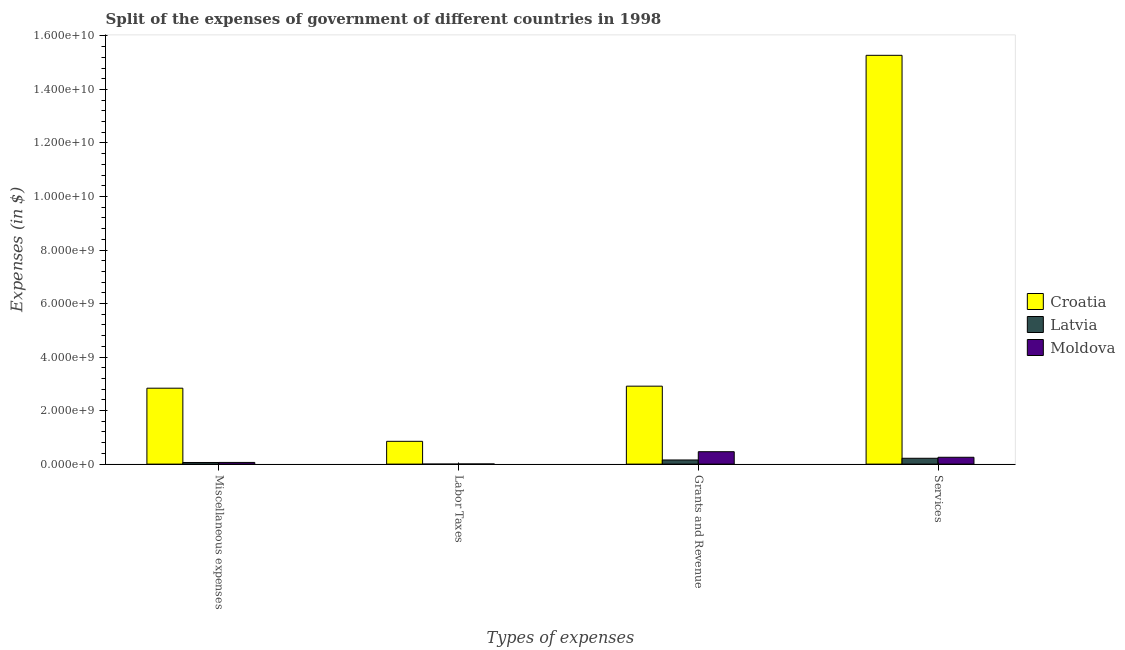Are the number of bars on each tick of the X-axis equal?
Ensure brevity in your answer.  Yes. How many bars are there on the 2nd tick from the left?
Offer a very short reply. 3. What is the label of the 4th group of bars from the left?
Keep it short and to the point. Services. What is the amount spent on labor taxes in Latvia?
Provide a succinct answer. 1.10e+05. Across all countries, what is the maximum amount spent on miscellaneous expenses?
Ensure brevity in your answer.  2.84e+09. Across all countries, what is the minimum amount spent on labor taxes?
Your answer should be very brief. 1.10e+05. In which country was the amount spent on miscellaneous expenses maximum?
Give a very brief answer. Croatia. In which country was the amount spent on labor taxes minimum?
Keep it short and to the point. Latvia. What is the total amount spent on grants and revenue in the graph?
Provide a short and direct response. 3.53e+09. What is the difference between the amount spent on labor taxes in Croatia and that in Moldova?
Provide a short and direct response. 8.46e+08. What is the difference between the amount spent on services in Latvia and the amount spent on labor taxes in Croatia?
Give a very brief answer. -6.33e+08. What is the average amount spent on grants and revenue per country?
Make the answer very short. 1.18e+09. What is the difference between the amount spent on miscellaneous expenses and amount spent on services in Croatia?
Offer a terse response. -1.24e+1. In how many countries, is the amount spent on grants and revenue greater than 400000000 $?
Give a very brief answer. 2. What is the ratio of the amount spent on miscellaneous expenses in Latvia to that in Croatia?
Your answer should be very brief. 0.02. Is the difference between the amount spent on labor taxes in Moldova and Latvia greater than the difference between the amount spent on miscellaneous expenses in Moldova and Latvia?
Your answer should be compact. Yes. What is the difference between the highest and the second highest amount spent on services?
Give a very brief answer. 1.50e+1. What is the difference between the highest and the lowest amount spent on services?
Offer a very short reply. 1.51e+1. Is it the case that in every country, the sum of the amount spent on miscellaneous expenses and amount spent on services is greater than the sum of amount spent on labor taxes and amount spent on grants and revenue?
Offer a very short reply. Yes. What does the 1st bar from the left in Labor Taxes represents?
Provide a succinct answer. Croatia. What does the 1st bar from the right in Miscellaneous expenses represents?
Your answer should be compact. Moldova. Is it the case that in every country, the sum of the amount spent on miscellaneous expenses and amount spent on labor taxes is greater than the amount spent on grants and revenue?
Provide a succinct answer. No. Are all the bars in the graph horizontal?
Give a very brief answer. No. How many countries are there in the graph?
Your answer should be compact. 3. How many legend labels are there?
Your response must be concise. 3. What is the title of the graph?
Make the answer very short. Split of the expenses of government of different countries in 1998. Does "Norway" appear as one of the legend labels in the graph?
Your answer should be compact. No. What is the label or title of the X-axis?
Keep it short and to the point. Types of expenses. What is the label or title of the Y-axis?
Provide a succinct answer. Expenses (in $). What is the Expenses (in $) of Croatia in Miscellaneous expenses?
Provide a short and direct response. 2.84e+09. What is the Expenses (in $) of Latvia in Miscellaneous expenses?
Ensure brevity in your answer.  6.06e+07. What is the Expenses (in $) in Moldova in Miscellaneous expenses?
Offer a very short reply. 6.28e+07. What is the Expenses (in $) in Croatia in Labor Taxes?
Give a very brief answer. 8.52e+08. What is the Expenses (in $) in Latvia in Labor Taxes?
Your response must be concise. 1.10e+05. What is the Expenses (in $) of Moldova in Labor Taxes?
Provide a short and direct response. 5.40e+06. What is the Expenses (in $) in Croatia in Grants and Revenue?
Provide a succinct answer. 2.91e+09. What is the Expenses (in $) in Latvia in Grants and Revenue?
Provide a succinct answer. 1.55e+08. What is the Expenses (in $) in Moldova in Grants and Revenue?
Provide a short and direct response. 4.64e+08. What is the Expenses (in $) of Croatia in Services?
Your answer should be very brief. 1.53e+1. What is the Expenses (in $) of Latvia in Services?
Provide a succinct answer. 2.18e+08. What is the Expenses (in $) in Moldova in Services?
Offer a terse response. 2.55e+08. Across all Types of expenses, what is the maximum Expenses (in $) in Croatia?
Your answer should be compact. 1.53e+1. Across all Types of expenses, what is the maximum Expenses (in $) in Latvia?
Your response must be concise. 2.18e+08. Across all Types of expenses, what is the maximum Expenses (in $) in Moldova?
Make the answer very short. 4.64e+08. Across all Types of expenses, what is the minimum Expenses (in $) of Croatia?
Give a very brief answer. 8.52e+08. Across all Types of expenses, what is the minimum Expenses (in $) in Moldova?
Provide a succinct answer. 5.40e+06. What is the total Expenses (in $) of Croatia in the graph?
Your answer should be very brief. 2.19e+1. What is the total Expenses (in $) in Latvia in the graph?
Provide a succinct answer. 4.34e+08. What is the total Expenses (in $) in Moldova in the graph?
Your answer should be compact. 7.87e+08. What is the difference between the Expenses (in $) in Croatia in Miscellaneous expenses and that in Labor Taxes?
Give a very brief answer. 1.98e+09. What is the difference between the Expenses (in $) of Latvia in Miscellaneous expenses and that in Labor Taxes?
Provide a succinct answer. 6.05e+07. What is the difference between the Expenses (in $) in Moldova in Miscellaneous expenses and that in Labor Taxes?
Offer a very short reply. 5.74e+07. What is the difference between the Expenses (in $) of Croatia in Miscellaneous expenses and that in Grants and Revenue?
Ensure brevity in your answer.  -7.59e+07. What is the difference between the Expenses (in $) in Latvia in Miscellaneous expenses and that in Grants and Revenue?
Offer a terse response. -9.43e+07. What is the difference between the Expenses (in $) in Moldova in Miscellaneous expenses and that in Grants and Revenue?
Your response must be concise. -4.01e+08. What is the difference between the Expenses (in $) in Croatia in Miscellaneous expenses and that in Services?
Provide a succinct answer. -1.24e+1. What is the difference between the Expenses (in $) of Latvia in Miscellaneous expenses and that in Services?
Your response must be concise. -1.58e+08. What is the difference between the Expenses (in $) in Moldova in Miscellaneous expenses and that in Services?
Make the answer very short. -1.93e+08. What is the difference between the Expenses (in $) in Croatia in Labor Taxes and that in Grants and Revenue?
Offer a very short reply. -2.06e+09. What is the difference between the Expenses (in $) of Latvia in Labor Taxes and that in Grants and Revenue?
Offer a very short reply. -1.55e+08. What is the difference between the Expenses (in $) in Moldova in Labor Taxes and that in Grants and Revenue?
Give a very brief answer. -4.58e+08. What is the difference between the Expenses (in $) of Croatia in Labor Taxes and that in Services?
Your answer should be very brief. -1.44e+1. What is the difference between the Expenses (in $) in Latvia in Labor Taxes and that in Services?
Ensure brevity in your answer.  -2.18e+08. What is the difference between the Expenses (in $) in Moldova in Labor Taxes and that in Services?
Keep it short and to the point. -2.50e+08. What is the difference between the Expenses (in $) of Croatia in Grants and Revenue and that in Services?
Your answer should be very brief. -1.24e+1. What is the difference between the Expenses (in $) of Latvia in Grants and Revenue and that in Services?
Offer a terse response. -6.35e+07. What is the difference between the Expenses (in $) of Moldova in Grants and Revenue and that in Services?
Give a very brief answer. 2.08e+08. What is the difference between the Expenses (in $) of Croatia in Miscellaneous expenses and the Expenses (in $) of Latvia in Labor Taxes?
Your answer should be compact. 2.84e+09. What is the difference between the Expenses (in $) of Croatia in Miscellaneous expenses and the Expenses (in $) of Moldova in Labor Taxes?
Keep it short and to the point. 2.83e+09. What is the difference between the Expenses (in $) in Latvia in Miscellaneous expenses and the Expenses (in $) in Moldova in Labor Taxes?
Offer a very short reply. 5.52e+07. What is the difference between the Expenses (in $) of Croatia in Miscellaneous expenses and the Expenses (in $) of Latvia in Grants and Revenue?
Provide a succinct answer. 2.68e+09. What is the difference between the Expenses (in $) of Croatia in Miscellaneous expenses and the Expenses (in $) of Moldova in Grants and Revenue?
Keep it short and to the point. 2.37e+09. What is the difference between the Expenses (in $) of Latvia in Miscellaneous expenses and the Expenses (in $) of Moldova in Grants and Revenue?
Provide a succinct answer. -4.03e+08. What is the difference between the Expenses (in $) of Croatia in Miscellaneous expenses and the Expenses (in $) of Latvia in Services?
Offer a very short reply. 2.62e+09. What is the difference between the Expenses (in $) of Croatia in Miscellaneous expenses and the Expenses (in $) of Moldova in Services?
Offer a terse response. 2.58e+09. What is the difference between the Expenses (in $) of Latvia in Miscellaneous expenses and the Expenses (in $) of Moldova in Services?
Provide a short and direct response. -1.95e+08. What is the difference between the Expenses (in $) of Croatia in Labor Taxes and the Expenses (in $) of Latvia in Grants and Revenue?
Provide a succinct answer. 6.97e+08. What is the difference between the Expenses (in $) in Croatia in Labor Taxes and the Expenses (in $) in Moldova in Grants and Revenue?
Ensure brevity in your answer.  3.88e+08. What is the difference between the Expenses (in $) in Latvia in Labor Taxes and the Expenses (in $) in Moldova in Grants and Revenue?
Make the answer very short. -4.64e+08. What is the difference between the Expenses (in $) of Croatia in Labor Taxes and the Expenses (in $) of Latvia in Services?
Provide a short and direct response. 6.33e+08. What is the difference between the Expenses (in $) of Croatia in Labor Taxes and the Expenses (in $) of Moldova in Services?
Provide a short and direct response. 5.96e+08. What is the difference between the Expenses (in $) in Latvia in Labor Taxes and the Expenses (in $) in Moldova in Services?
Provide a succinct answer. -2.55e+08. What is the difference between the Expenses (in $) in Croatia in Grants and Revenue and the Expenses (in $) in Latvia in Services?
Your answer should be very brief. 2.69e+09. What is the difference between the Expenses (in $) of Croatia in Grants and Revenue and the Expenses (in $) of Moldova in Services?
Your response must be concise. 2.66e+09. What is the difference between the Expenses (in $) in Latvia in Grants and Revenue and the Expenses (in $) in Moldova in Services?
Provide a succinct answer. -1.01e+08. What is the average Expenses (in $) in Croatia per Types of expenses?
Your answer should be compact. 5.47e+09. What is the average Expenses (in $) in Latvia per Types of expenses?
Keep it short and to the point. 1.08e+08. What is the average Expenses (in $) in Moldova per Types of expenses?
Your answer should be compact. 1.97e+08. What is the difference between the Expenses (in $) in Croatia and Expenses (in $) in Latvia in Miscellaneous expenses?
Give a very brief answer. 2.78e+09. What is the difference between the Expenses (in $) in Croatia and Expenses (in $) in Moldova in Miscellaneous expenses?
Make the answer very short. 2.77e+09. What is the difference between the Expenses (in $) in Latvia and Expenses (in $) in Moldova in Miscellaneous expenses?
Offer a very short reply. -2.22e+06. What is the difference between the Expenses (in $) in Croatia and Expenses (in $) in Latvia in Labor Taxes?
Make the answer very short. 8.52e+08. What is the difference between the Expenses (in $) of Croatia and Expenses (in $) of Moldova in Labor Taxes?
Offer a very short reply. 8.46e+08. What is the difference between the Expenses (in $) in Latvia and Expenses (in $) in Moldova in Labor Taxes?
Offer a very short reply. -5.29e+06. What is the difference between the Expenses (in $) of Croatia and Expenses (in $) of Latvia in Grants and Revenue?
Keep it short and to the point. 2.76e+09. What is the difference between the Expenses (in $) of Croatia and Expenses (in $) of Moldova in Grants and Revenue?
Your response must be concise. 2.45e+09. What is the difference between the Expenses (in $) in Latvia and Expenses (in $) in Moldova in Grants and Revenue?
Provide a short and direct response. -3.09e+08. What is the difference between the Expenses (in $) in Croatia and Expenses (in $) in Latvia in Services?
Make the answer very short. 1.51e+1. What is the difference between the Expenses (in $) in Croatia and Expenses (in $) in Moldova in Services?
Offer a very short reply. 1.50e+1. What is the difference between the Expenses (in $) of Latvia and Expenses (in $) of Moldova in Services?
Your answer should be very brief. -3.70e+07. What is the ratio of the Expenses (in $) in Croatia in Miscellaneous expenses to that in Labor Taxes?
Ensure brevity in your answer.  3.33. What is the ratio of the Expenses (in $) in Latvia in Miscellaneous expenses to that in Labor Taxes?
Your answer should be very brief. 550.73. What is the ratio of the Expenses (in $) in Moldova in Miscellaneous expenses to that in Labor Taxes?
Offer a very short reply. 11.63. What is the ratio of the Expenses (in $) in Croatia in Miscellaneous expenses to that in Grants and Revenue?
Your response must be concise. 0.97. What is the ratio of the Expenses (in $) in Latvia in Miscellaneous expenses to that in Grants and Revenue?
Offer a very short reply. 0.39. What is the ratio of the Expenses (in $) in Moldova in Miscellaneous expenses to that in Grants and Revenue?
Your answer should be compact. 0.14. What is the ratio of the Expenses (in $) in Croatia in Miscellaneous expenses to that in Services?
Keep it short and to the point. 0.19. What is the ratio of the Expenses (in $) of Latvia in Miscellaneous expenses to that in Services?
Ensure brevity in your answer.  0.28. What is the ratio of the Expenses (in $) in Moldova in Miscellaneous expenses to that in Services?
Your response must be concise. 0.25. What is the ratio of the Expenses (in $) of Croatia in Labor Taxes to that in Grants and Revenue?
Offer a terse response. 0.29. What is the ratio of the Expenses (in $) of Latvia in Labor Taxes to that in Grants and Revenue?
Make the answer very short. 0. What is the ratio of the Expenses (in $) in Moldova in Labor Taxes to that in Grants and Revenue?
Your answer should be compact. 0.01. What is the ratio of the Expenses (in $) in Croatia in Labor Taxes to that in Services?
Offer a very short reply. 0.06. What is the ratio of the Expenses (in $) of Latvia in Labor Taxes to that in Services?
Your response must be concise. 0. What is the ratio of the Expenses (in $) of Moldova in Labor Taxes to that in Services?
Keep it short and to the point. 0.02. What is the ratio of the Expenses (in $) in Croatia in Grants and Revenue to that in Services?
Your answer should be compact. 0.19. What is the ratio of the Expenses (in $) of Latvia in Grants and Revenue to that in Services?
Give a very brief answer. 0.71. What is the ratio of the Expenses (in $) in Moldova in Grants and Revenue to that in Services?
Provide a short and direct response. 1.82. What is the difference between the highest and the second highest Expenses (in $) in Croatia?
Your answer should be very brief. 1.24e+1. What is the difference between the highest and the second highest Expenses (in $) of Latvia?
Your answer should be compact. 6.35e+07. What is the difference between the highest and the second highest Expenses (in $) in Moldova?
Make the answer very short. 2.08e+08. What is the difference between the highest and the lowest Expenses (in $) of Croatia?
Provide a succinct answer. 1.44e+1. What is the difference between the highest and the lowest Expenses (in $) of Latvia?
Offer a very short reply. 2.18e+08. What is the difference between the highest and the lowest Expenses (in $) in Moldova?
Offer a terse response. 4.58e+08. 